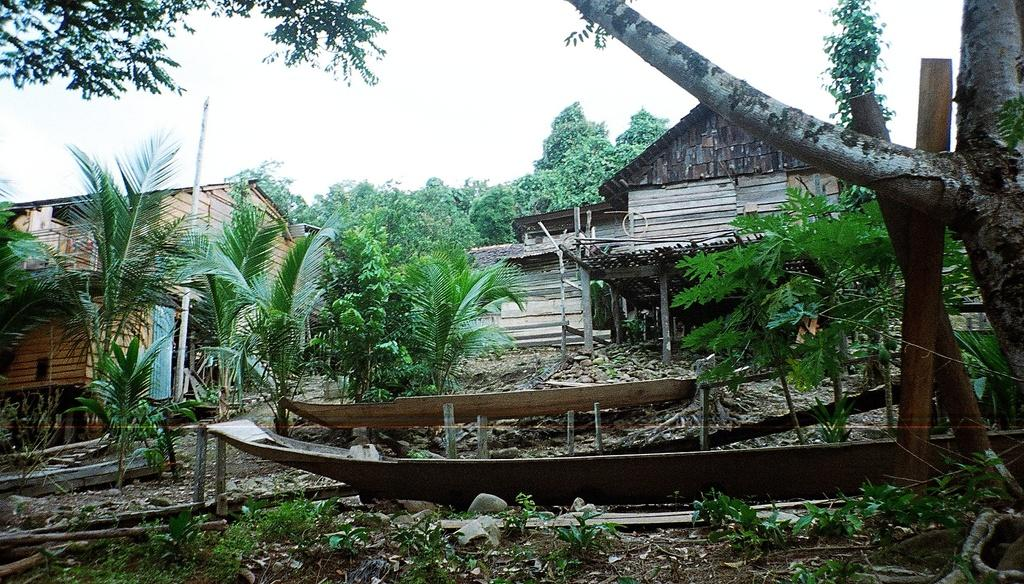What type of house is shown in the image? There is a wooden house in the image. What can be seen in the background of the image? There are trees in the image. What material is used for the decor in the image? There is wood decor in the image. What type of magic is being performed in the image? There is no magic being performed in the image; it features a wooden house, trees, and wood decor. What is the zinc content of the wooden house in the image? There is no mention of zinc content in the image, as it focuses on the wooden house, trees, and wood decor. 